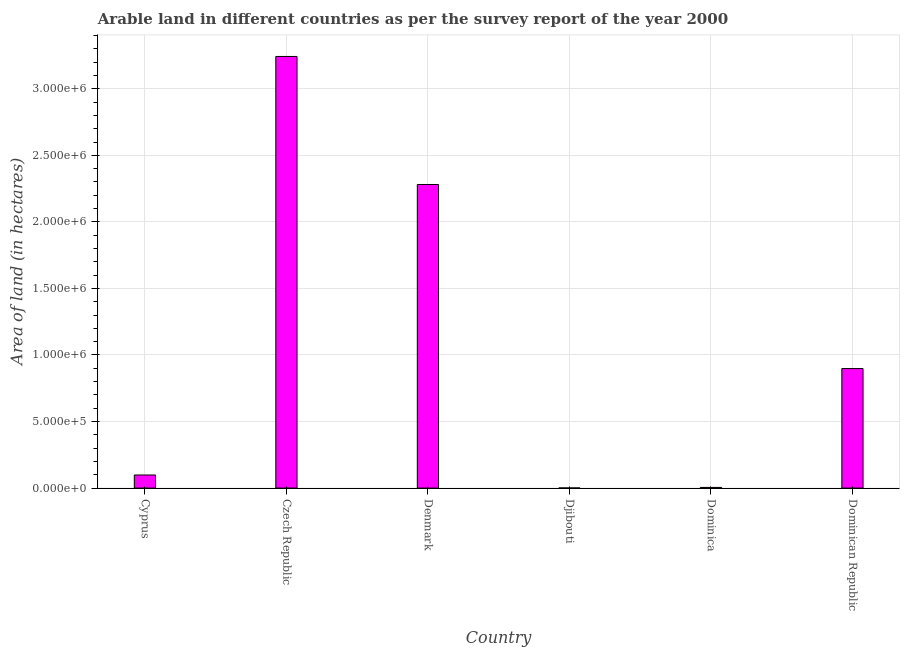Does the graph contain grids?
Your answer should be very brief. Yes. What is the title of the graph?
Offer a very short reply. Arable land in different countries as per the survey report of the year 2000. What is the label or title of the X-axis?
Give a very brief answer. Country. What is the label or title of the Y-axis?
Provide a succinct answer. Area of land (in hectares). What is the area of land in Denmark?
Your response must be concise. 2.28e+06. Across all countries, what is the maximum area of land?
Provide a succinct answer. 3.24e+06. Across all countries, what is the minimum area of land?
Your answer should be compact. 1000. In which country was the area of land maximum?
Ensure brevity in your answer.  Czech Republic. In which country was the area of land minimum?
Your answer should be very brief. Djibouti. What is the sum of the area of land?
Offer a very short reply. 6.53e+06. What is the difference between the area of land in Cyprus and Dominica?
Your answer should be compact. 9.34e+04. What is the average area of land per country?
Your answer should be compact. 1.09e+06. What is the median area of land?
Your answer should be compact. 4.98e+05. What is the ratio of the area of land in Denmark to that in Djibouti?
Offer a terse response. 2281. Is the difference between the area of land in Cyprus and Dominica greater than the difference between any two countries?
Provide a short and direct response. No. What is the difference between the highest and the second highest area of land?
Your response must be concise. 9.62e+05. Is the sum of the area of land in Djibouti and Dominica greater than the maximum area of land across all countries?
Provide a succinct answer. No. What is the difference between the highest and the lowest area of land?
Offer a terse response. 3.24e+06. How many bars are there?
Ensure brevity in your answer.  6. What is the difference between two consecutive major ticks on the Y-axis?
Keep it short and to the point. 5.00e+05. Are the values on the major ticks of Y-axis written in scientific E-notation?
Provide a short and direct response. Yes. What is the Area of land (in hectares) in Cyprus?
Ensure brevity in your answer.  9.84e+04. What is the Area of land (in hectares) of Czech Republic?
Offer a very short reply. 3.24e+06. What is the Area of land (in hectares) of Denmark?
Provide a succinct answer. 2.28e+06. What is the Area of land (in hectares) of Dominican Republic?
Provide a succinct answer. 8.98e+05. What is the difference between the Area of land (in hectares) in Cyprus and Czech Republic?
Ensure brevity in your answer.  -3.14e+06. What is the difference between the Area of land (in hectares) in Cyprus and Denmark?
Make the answer very short. -2.18e+06. What is the difference between the Area of land (in hectares) in Cyprus and Djibouti?
Offer a terse response. 9.74e+04. What is the difference between the Area of land (in hectares) in Cyprus and Dominica?
Ensure brevity in your answer.  9.34e+04. What is the difference between the Area of land (in hectares) in Cyprus and Dominican Republic?
Your response must be concise. -8.00e+05. What is the difference between the Area of land (in hectares) in Czech Republic and Denmark?
Keep it short and to the point. 9.62e+05. What is the difference between the Area of land (in hectares) in Czech Republic and Djibouti?
Provide a succinct answer. 3.24e+06. What is the difference between the Area of land (in hectares) in Czech Republic and Dominica?
Make the answer very short. 3.24e+06. What is the difference between the Area of land (in hectares) in Czech Republic and Dominican Republic?
Keep it short and to the point. 2.34e+06. What is the difference between the Area of land (in hectares) in Denmark and Djibouti?
Provide a short and direct response. 2.28e+06. What is the difference between the Area of land (in hectares) in Denmark and Dominica?
Your answer should be compact. 2.28e+06. What is the difference between the Area of land (in hectares) in Denmark and Dominican Republic?
Your answer should be very brief. 1.38e+06. What is the difference between the Area of land (in hectares) in Djibouti and Dominica?
Make the answer very short. -4000. What is the difference between the Area of land (in hectares) in Djibouti and Dominican Republic?
Your response must be concise. -8.97e+05. What is the difference between the Area of land (in hectares) in Dominica and Dominican Republic?
Keep it short and to the point. -8.93e+05. What is the ratio of the Area of land (in hectares) in Cyprus to that in Denmark?
Ensure brevity in your answer.  0.04. What is the ratio of the Area of land (in hectares) in Cyprus to that in Djibouti?
Offer a terse response. 98.4. What is the ratio of the Area of land (in hectares) in Cyprus to that in Dominica?
Offer a very short reply. 19.68. What is the ratio of the Area of land (in hectares) in Cyprus to that in Dominican Republic?
Provide a succinct answer. 0.11. What is the ratio of the Area of land (in hectares) in Czech Republic to that in Denmark?
Give a very brief answer. 1.42. What is the ratio of the Area of land (in hectares) in Czech Republic to that in Djibouti?
Provide a short and direct response. 3243. What is the ratio of the Area of land (in hectares) in Czech Republic to that in Dominica?
Your answer should be compact. 648.6. What is the ratio of the Area of land (in hectares) in Czech Republic to that in Dominican Republic?
Give a very brief answer. 3.61. What is the ratio of the Area of land (in hectares) in Denmark to that in Djibouti?
Keep it short and to the point. 2281. What is the ratio of the Area of land (in hectares) in Denmark to that in Dominica?
Ensure brevity in your answer.  456.2. What is the ratio of the Area of land (in hectares) in Denmark to that in Dominican Republic?
Your response must be concise. 2.54. What is the ratio of the Area of land (in hectares) in Djibouti to that in Dominican Republic?
Your answer should be compact. 0. What is the ratio of the Area of land (in hectares) in Dominica to that in Dominican Republic?
Ensure brevity in your answer.  0.01. 